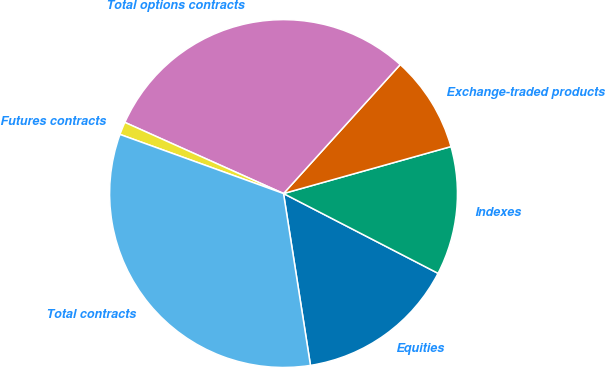Convert chart. <chart><loc_0><loc_0><loc_500><loc_500><pie_chart><fcel>Equities<fcel>Indexes<fcel>Exchange-traded products<fcel>Total options contracts<fcel>Futures contracts<fcel>Total contracts<nl><fcel>14.94%<fcel>11.94%<fcel>8.94%<fcel>30.0%<fcel>1.19%<fcel>33.0%<nl></chart> 